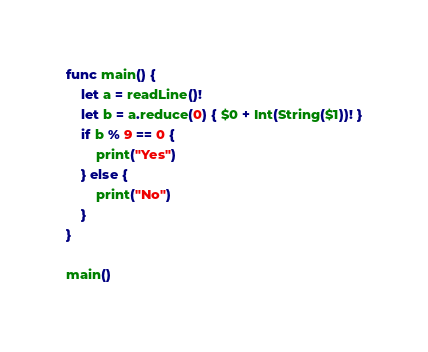<code> <loc_0><loc_0><loc_500><loc_500><_Swift_>func main() {
    let a = readLine()!
    let b = a.reduce(0) { $0 + Int(String($1))! }
    if b % 9 == 0 {
        print("Yes")
    } else {
        print("No")
    }
}

main()
</code> 